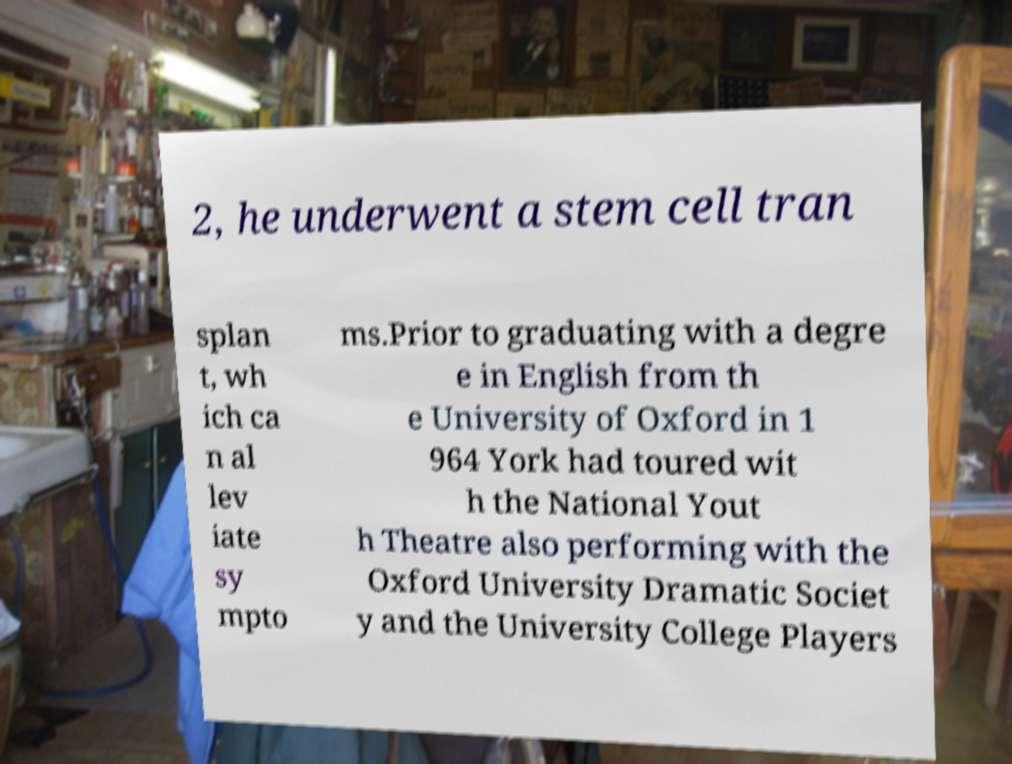Can you read and provide the text displayed in the image?This photo seems to have some interesting text. Can you extract and type it out for me? 2, he underwent a stem cell tran splan t, wh ich ca n al lev iate sy mpto ms.Prior to graduating with a degre e in English from th e University of Oxford in 1 964 York had toured wit h the National Yout h Theatre also performing with the Oxford University Dramatic Societ y and the University College Players 